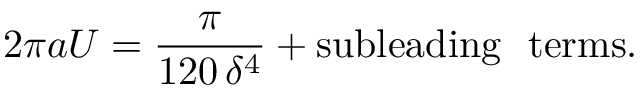<formula> <loc_0><loc_0><loc_500><loc_500>2 \pi a U = \frac { \pi } { 1 2 0 \, \delta ^ { 4 } } + s u b l e a d i n g t e r m s .</formula> 